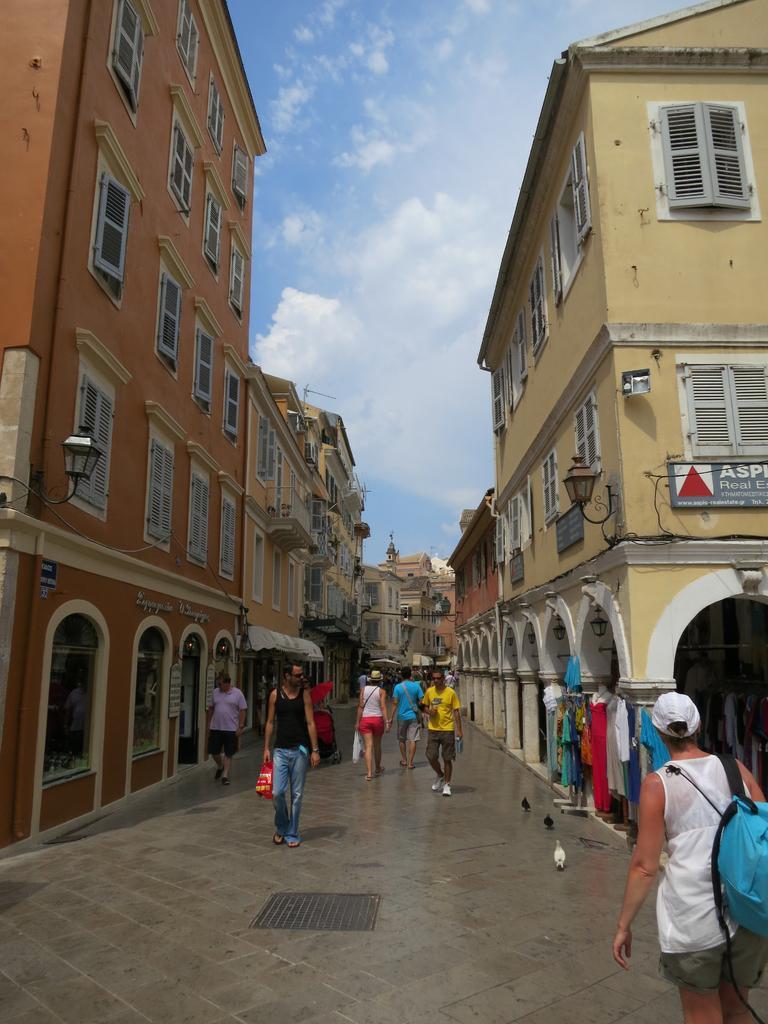Please provide a concise description of this image. In this image we can see people are walking on the road. Here we can see birds, clothes, mannequins, lights, boards, windows, and buildings. In the background there is sky with clouds. 